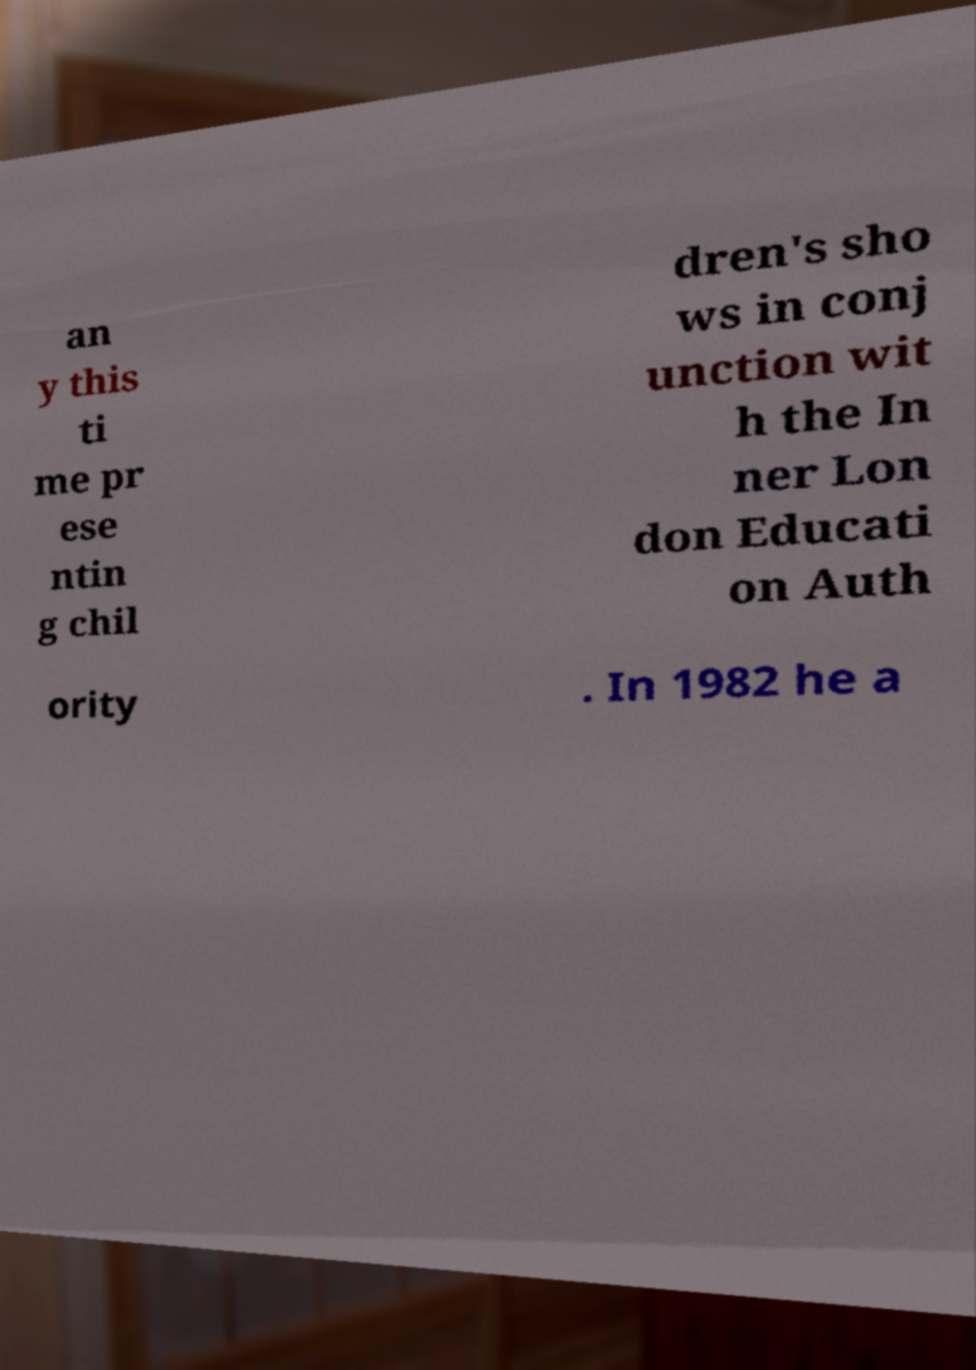For documentation purposes, I need the text within this image transcribed. Could you provide that? an y this ti me pr ese ntin g chil dren's sho ws in conj unction wit h the In ner Lon don Educati on Auth ority . In 1982 he a 